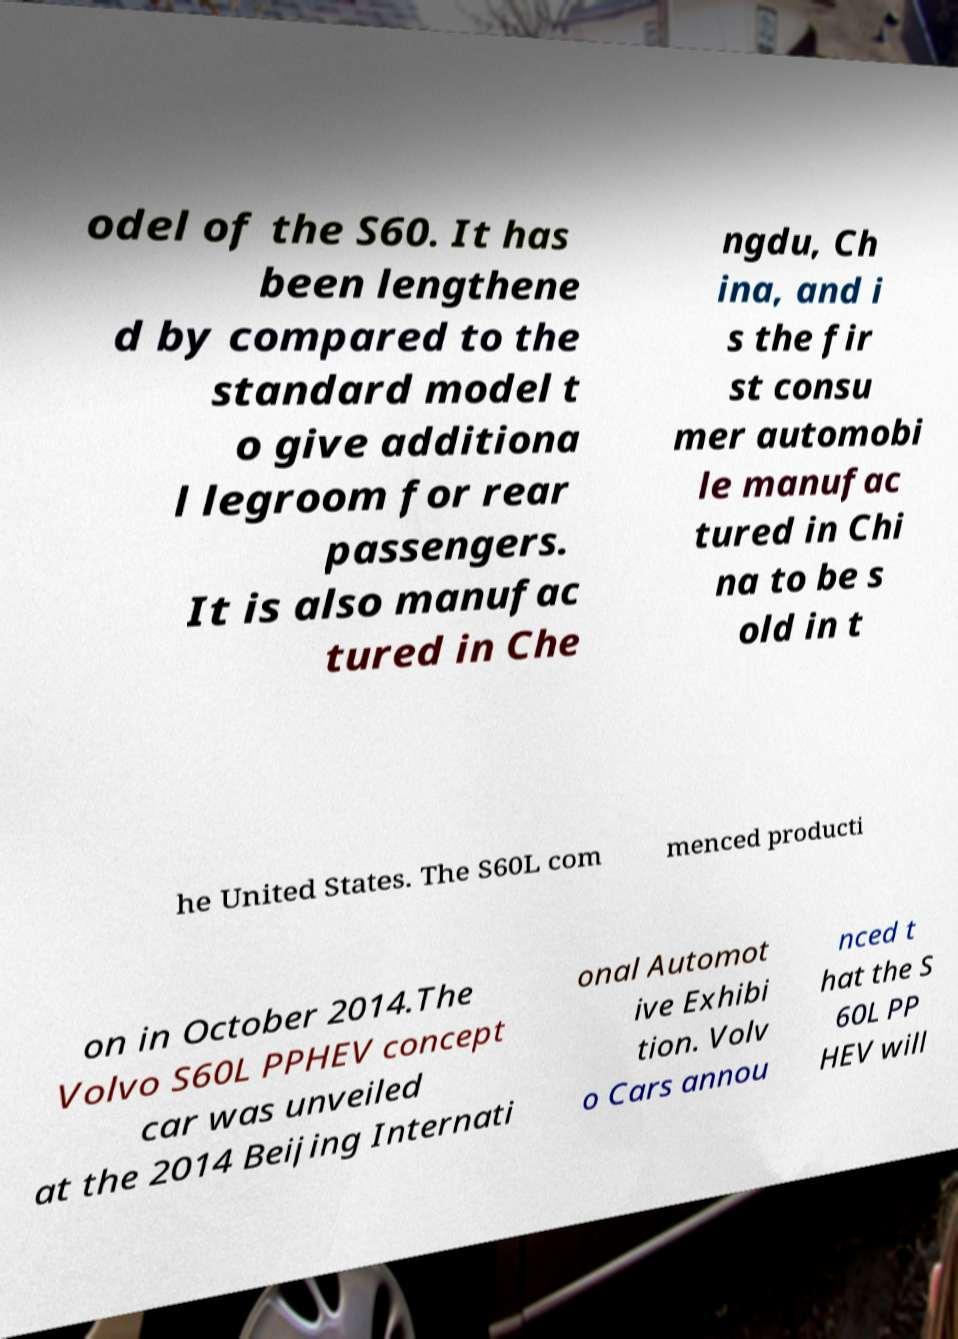What messages or text are displayed in this image? I need them in a readable, typed format. odel of the S60. It has been lengthene d by compared to the standard model t o give additiona l legroom for rear passengers. It is also manufac tured in Che ngdu, Ch ina, and i s the fir st consu mer automobi le manufac tured in Chi na to be s old in t he United States. The S60L com menced producti on in October 2014.The Volvo S60L PPHEV concept car was unveiled at the 2014 Beijing Internati onal Automot ive Exhibi tion. Volv o Cars annou nced t hat the S 60L PP HEV will 